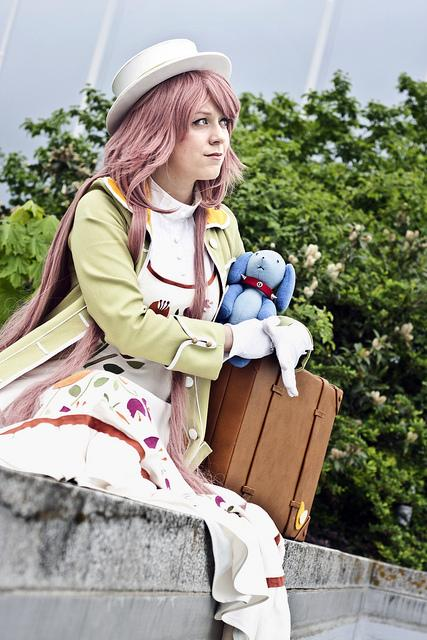What is next to the girl? suitcase 